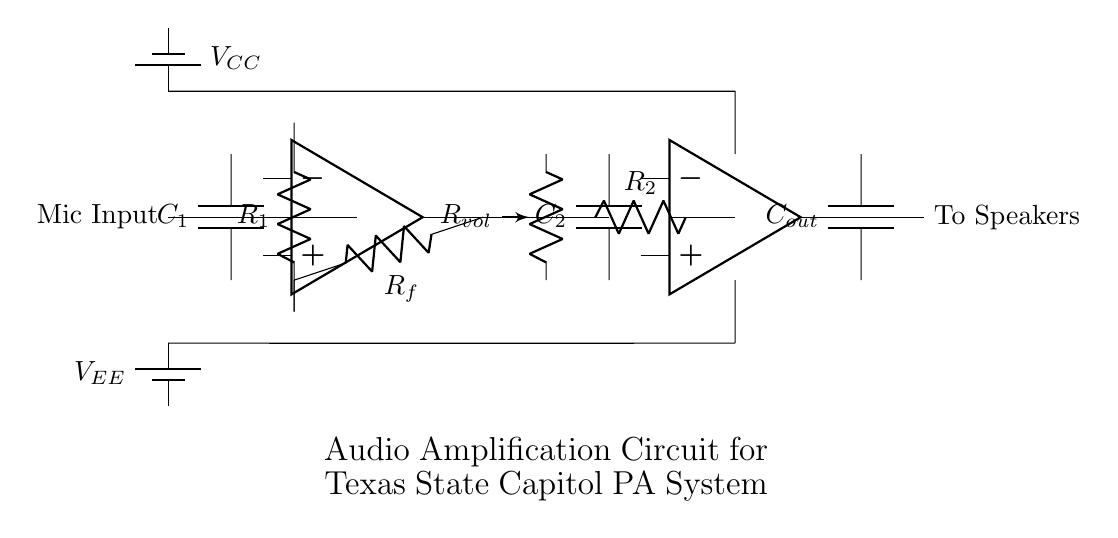What is the input component of the circuit? The input component, as shown in the circuit diagram, is labeled as "Mic Input," indicating that it is designed to receive audio signals from a microphone.
Answer: Mic Input What type of amplifiers are used in this circuit? There are two operational amplifiers in the circuit, each represented symbolically in the diagram. The first is responsible for signal pre-amplification, and the second is for power amplification.
Answer: Operational amplifiers How many resistors are included in the circuit? Analyzing the diagram, there are three resistors present; one is labeled "R1," a second is "R2," and the third, a feedback resistor, is labeled "Rf."
Answer: Three What is the purpose of the capacitor labeled C2? C2 in the circuit diagram acts as a tone control component, modifying the frequency response of the audio signal for better sound quality before amplification.
Answer: Tone control What is connected to the output of the second operational amplifier? The output of the second operational amplifier is connected to a capacitor labeled "Cout," which is likely used for output coupling to block DC voltage and allow AC audio signals to pass through to the speakers.
Answer: Cout How is the power supply configured in this circuit? The circuit features a dual power supply configuration, with one battery supplying positive voltage (Vcc) and another providing negative voltage (Vee), allowing the circuit to operate around ground potential effectively.
Answer: Dual supply 